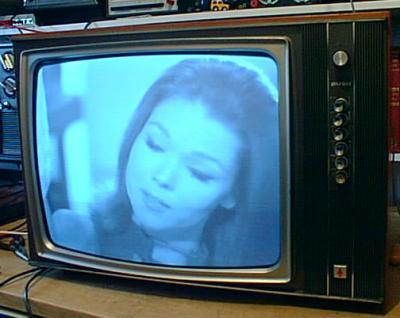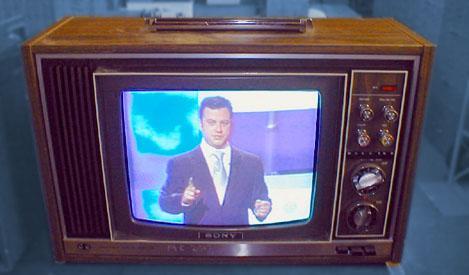The first image is the image on the left, the second image is the image on the right. Assess this claim about the two images: "In one image, a TV has a screen with left and right sides that are curved outward and a flat top and bottom.". Correct or not? Answer yes or no. No. 